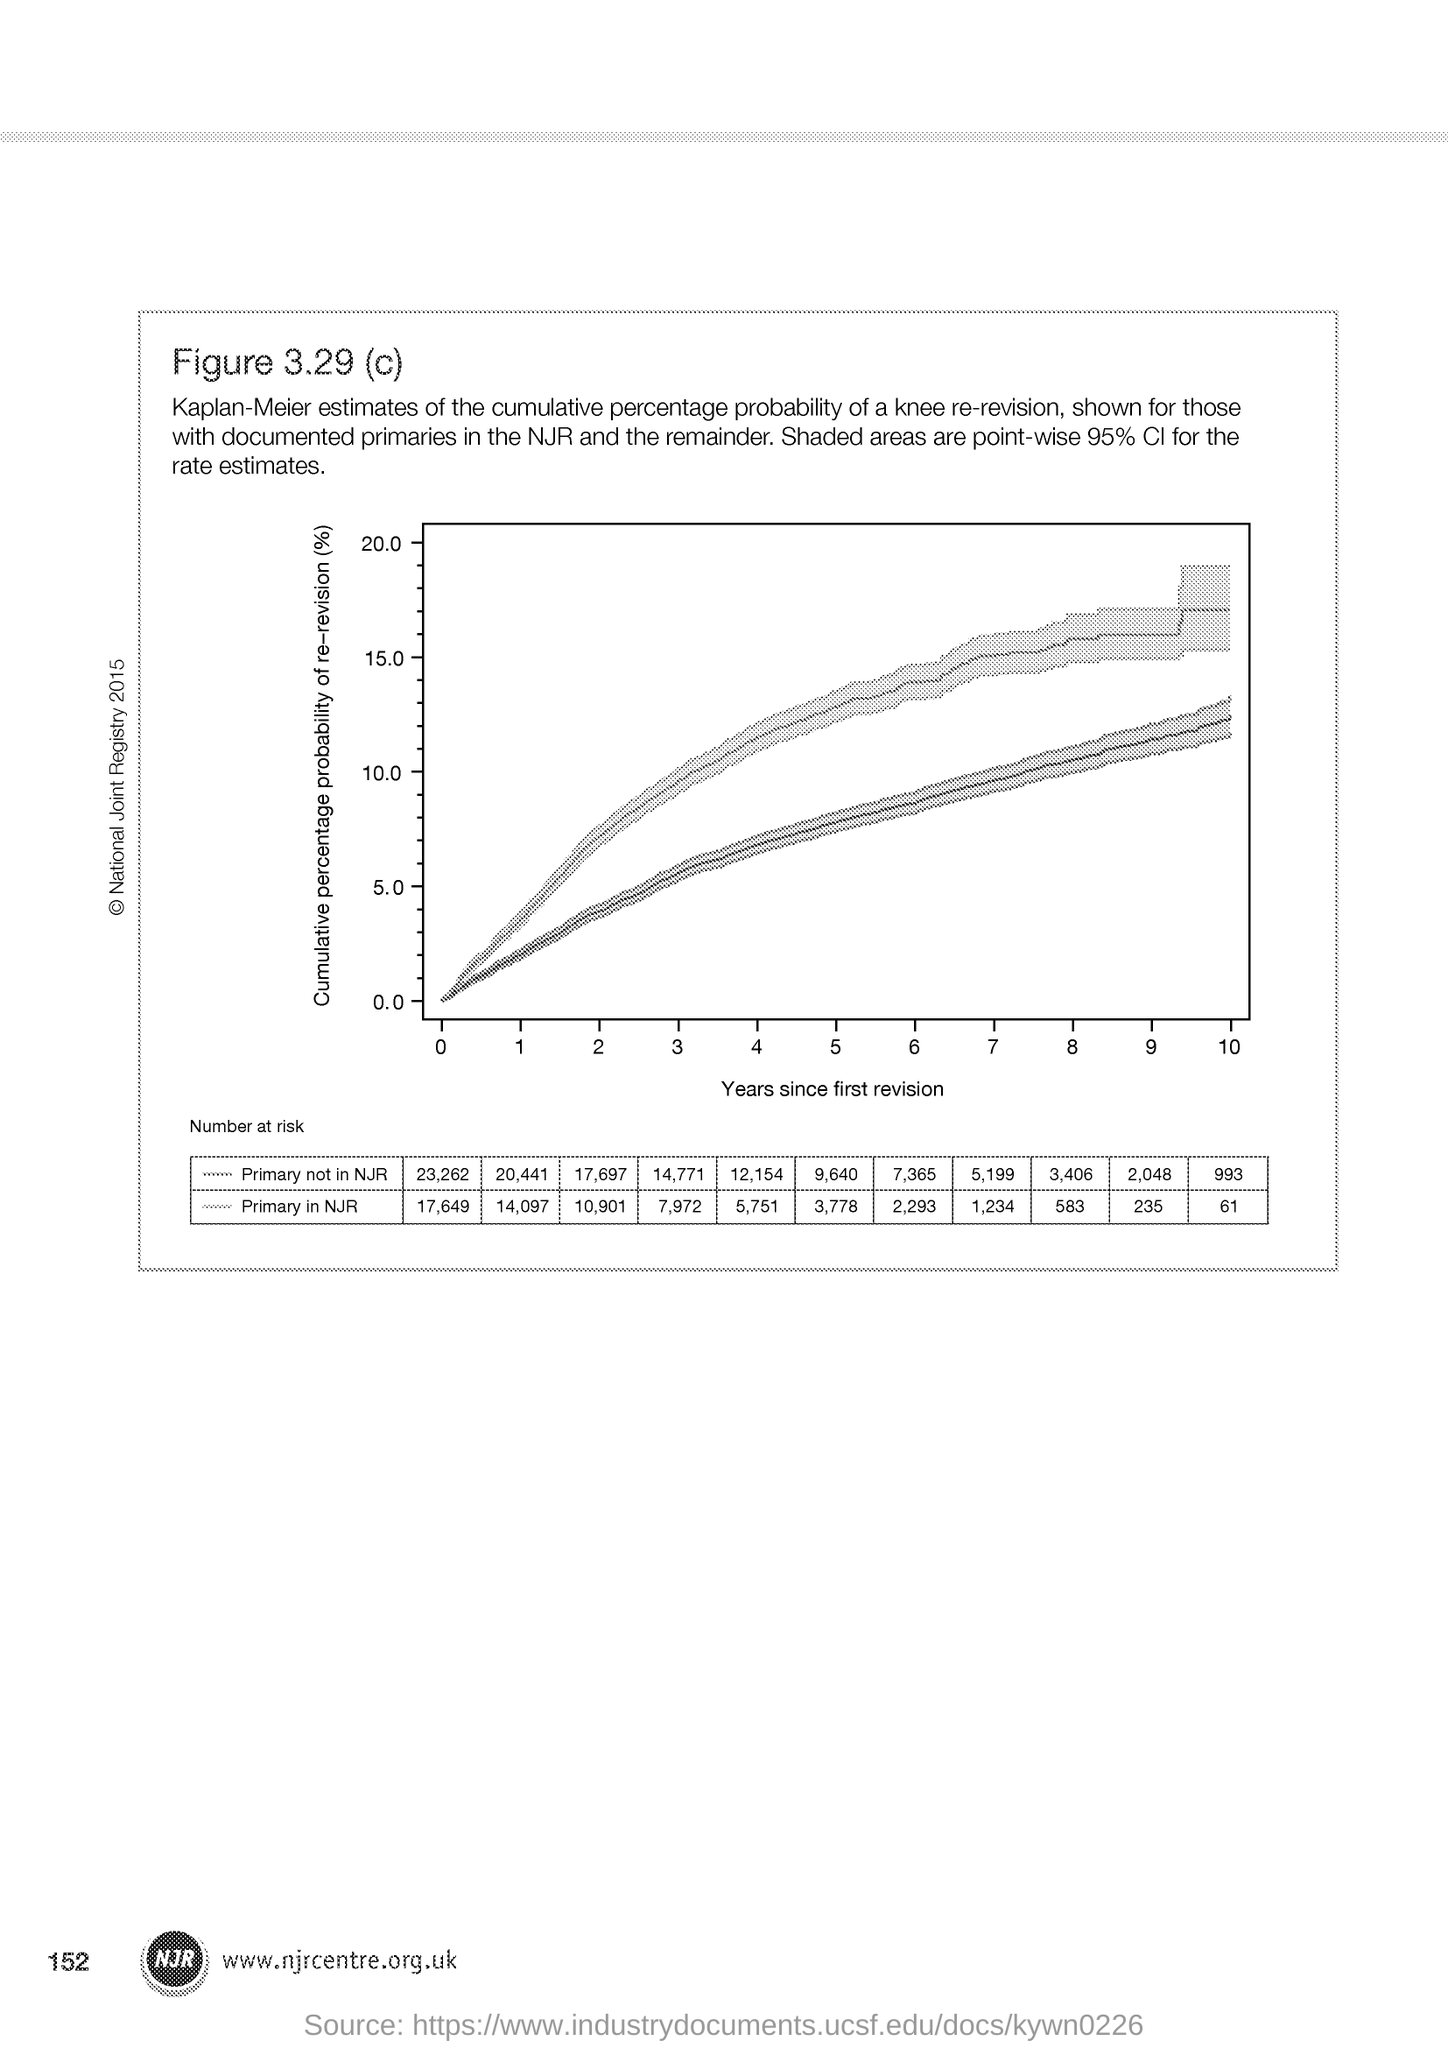Specify some key components in this picture. The page number is 152. The x-axis displays the years since the first revision for a particular case. 